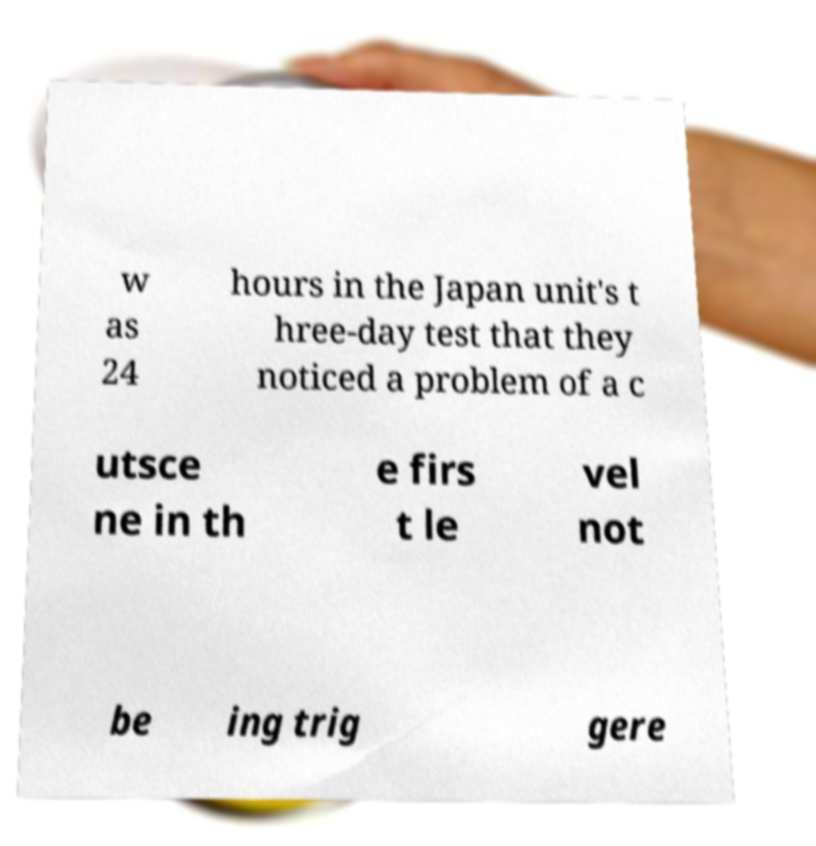Could you assist in decoding the text presented in this image and type it out clearly? w as 24 hours in the Japan unit's t hree-day test that they noticed a problem of a c utsce ne in th e firs t le vel not be ing trig gere 